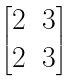Convert formula to latex. <formula><loc_0><loc_0><loc_500><loc_500>\begin{bmatrix} 2 & 3 \\ 2 & 3 \end{bmatrix}</formula> 